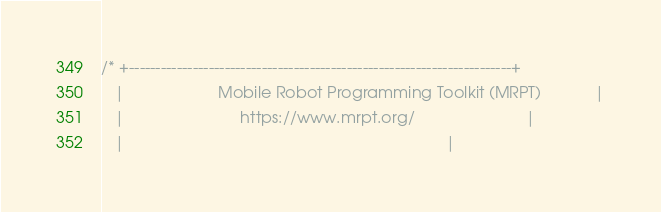Convert code to text. <code><loc_0><loc_0><loc_500><loc_500><_C_>/* +------------------------------------------------------------------------+
   |                     Mobile Robot Programming Toolkit (MRPT)            |
   |                          https://www.mrpt.org/                         |
   |                                                                        |</code> 